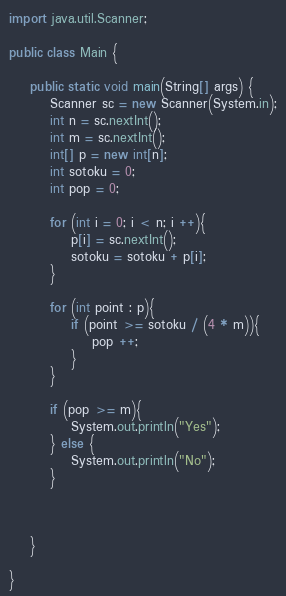Convert code to text. <code><loc_0><loc_0><loc_500><loc_500><_Java_>import java.util.Scanner;

public class Main {

	public static void main(String[] args) {
		Scanner sc = new Scanner(System.in);
		int n = sc.nextInt();
		int m = sc.nextInt();
		int[] p = new int[n];
		int sotoku = 0;
		int pop = 0;

		for (int i = 0; i < n; i ++){
			p[i] = sc.nextInt();
			sotoku = sotoku + p[i];
		}

		for (int point : p){
			if (point >= sotoku / (4 * m)){
				pop ++;
			}
		}

		if (pop >= m){
			System.out.println("Yes");
		} else {
			System.out.println("No");
		}



	}

}
</code> 